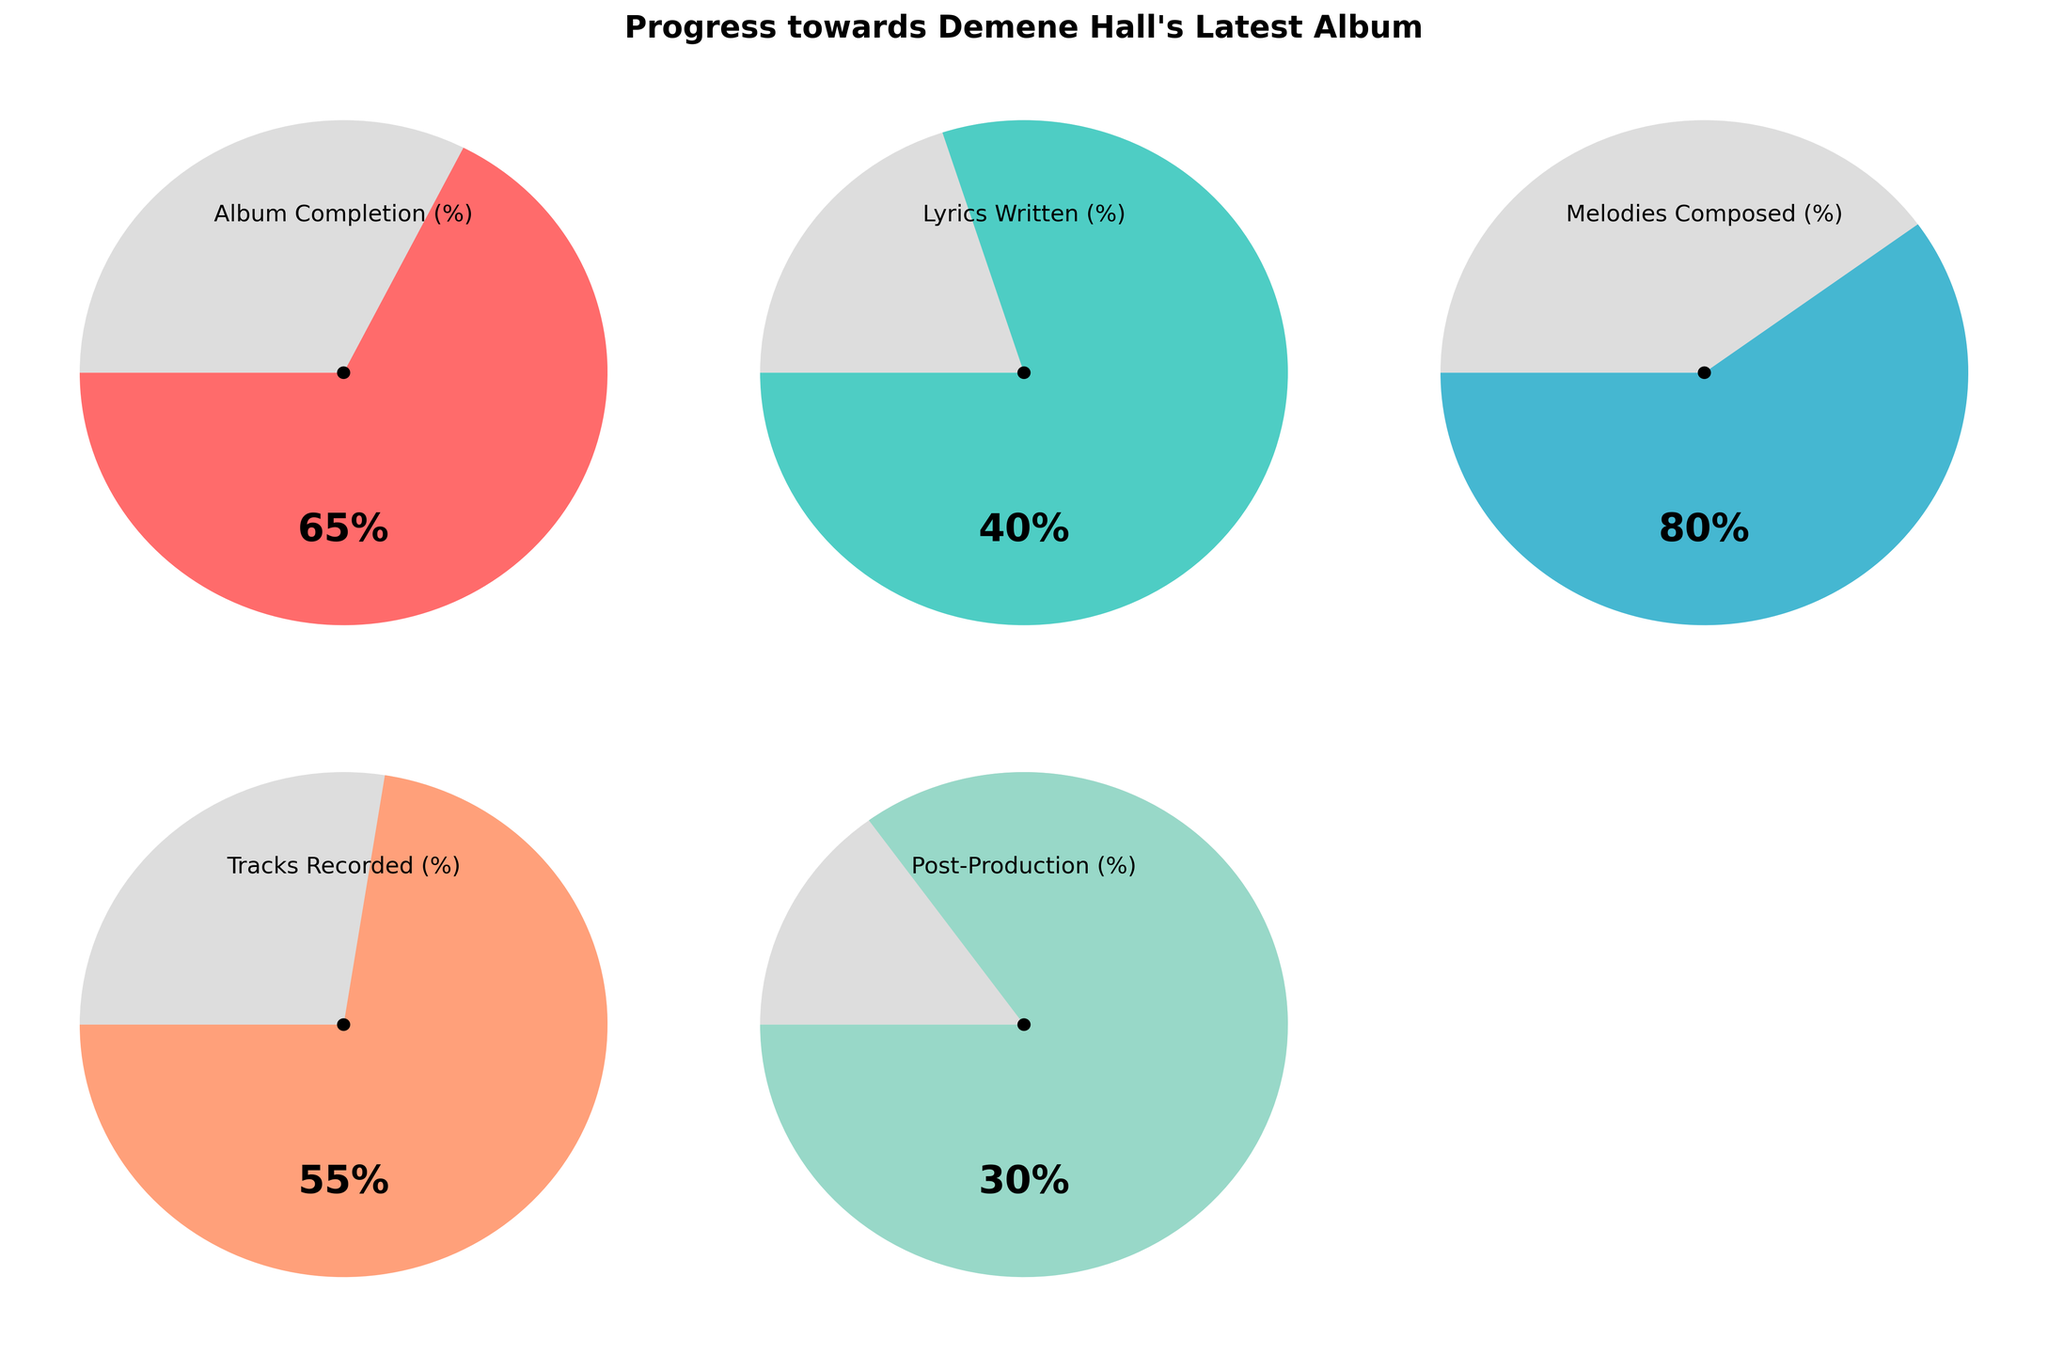What is the title of the figure? The title is usually located at the top and summarizes the content of the figure. Here, it reads "Progress towards Demene Hall's Latest Album"
Answer: Progress towards Demene Hall's Latest Album What is the percentage of melodies composed? Locate the gauge with the label "Melodies Composed (%)" and read its value. The needle is pointing at 80%.
Answer: 80% Which aspect of the album production has the lowest completion percentage? Compare the percentages on all gauges and identify the smallest value. The "Post-Production (%)" gauge shows the lowest at 30%.
Answer: Post-Production How much higher is the completion percentage of recording tracks compared to writing lyrics? Subtract the percentage of "Lyrics Written (%)" from the percentage of "Tracks Recorded (%)": 55% - 40% = 15%
Answer: 15% What is the average percentage completion across all aspects shown? Sum the percentages and divide by the number of gauges: (65% + 40% + 80% + 55% + 30%) / 5 = 54%
Answer: 54% How many aspects of the album production have a completion rate above 50%? Count the gauges with values above 50%. The gauges for "Album Completion", "Melodies Composed", and "Tracks Recorded" meet this criterion, totaling 3.
Answer: 3 Which percentage is greater, the completion of the lyrics written or the tracks recorded? Compare the values for "Lyrics Written" and "Tracks Recorded". Tracks Recorded has 55%, which is higher than Lyrics Written at 40%.
Answer: Tracks Recorded What color represents the gauge with the highest percentage? Identify the gauge with the highest percentage (Melodies Composed, 80%) and note its color, which is a shade of light turquoise.
Answer: light turquoise Given that Post-Production is at 30%, how much more percentage needs to be completed to reach 100%? Subtract the given percentage from 100%: 100% - 30% = 70%
Answer: 70% What is the relationship between the percentage of Album Completion and Melodies Composed? Compare both percentages: Album Completion is 65%, and Melodies Composed is 80%. Thus, Melodies Composed is higher.
Answer: Melodies Composed is higher 